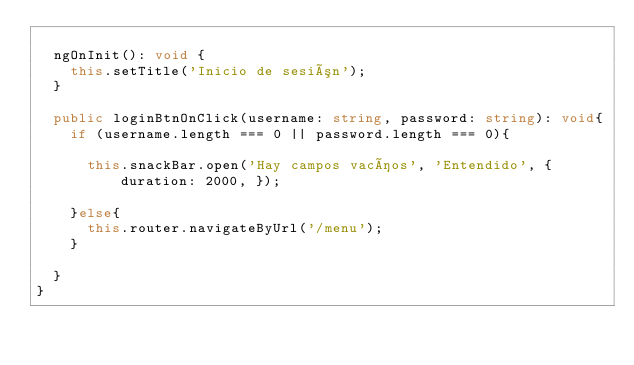<code> <loc_0><loc_0><loc_500><loc_500><_TypeScript_>
  ngOnInit(): void {
    this.setTitle('Inicio de sesión');
  }

  public loginBtnOnClick(username: string, password: string): void{
    if (username.length === 0 || password.length === 0){

      this.snackBar.open('Hay campos vacíos', 'Entendido', { duration: 2000, });

    }else{
      this.router.navigateByUrl('/menu');
    }

  }
}
</code> 